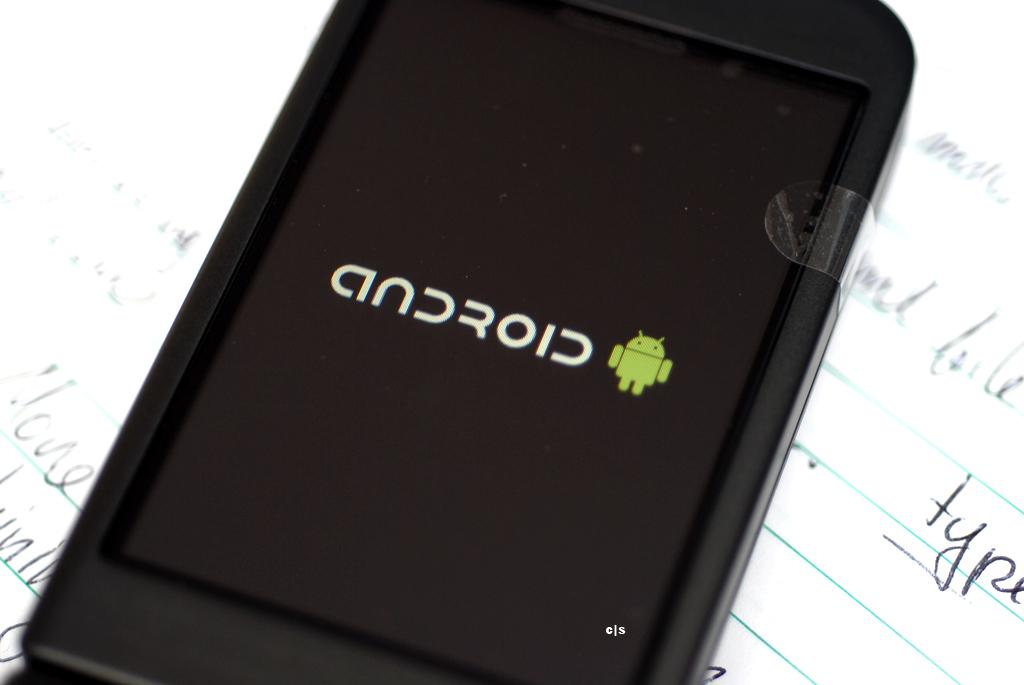What is written on this phone?
Ensure brevity in your answer.  Android. 